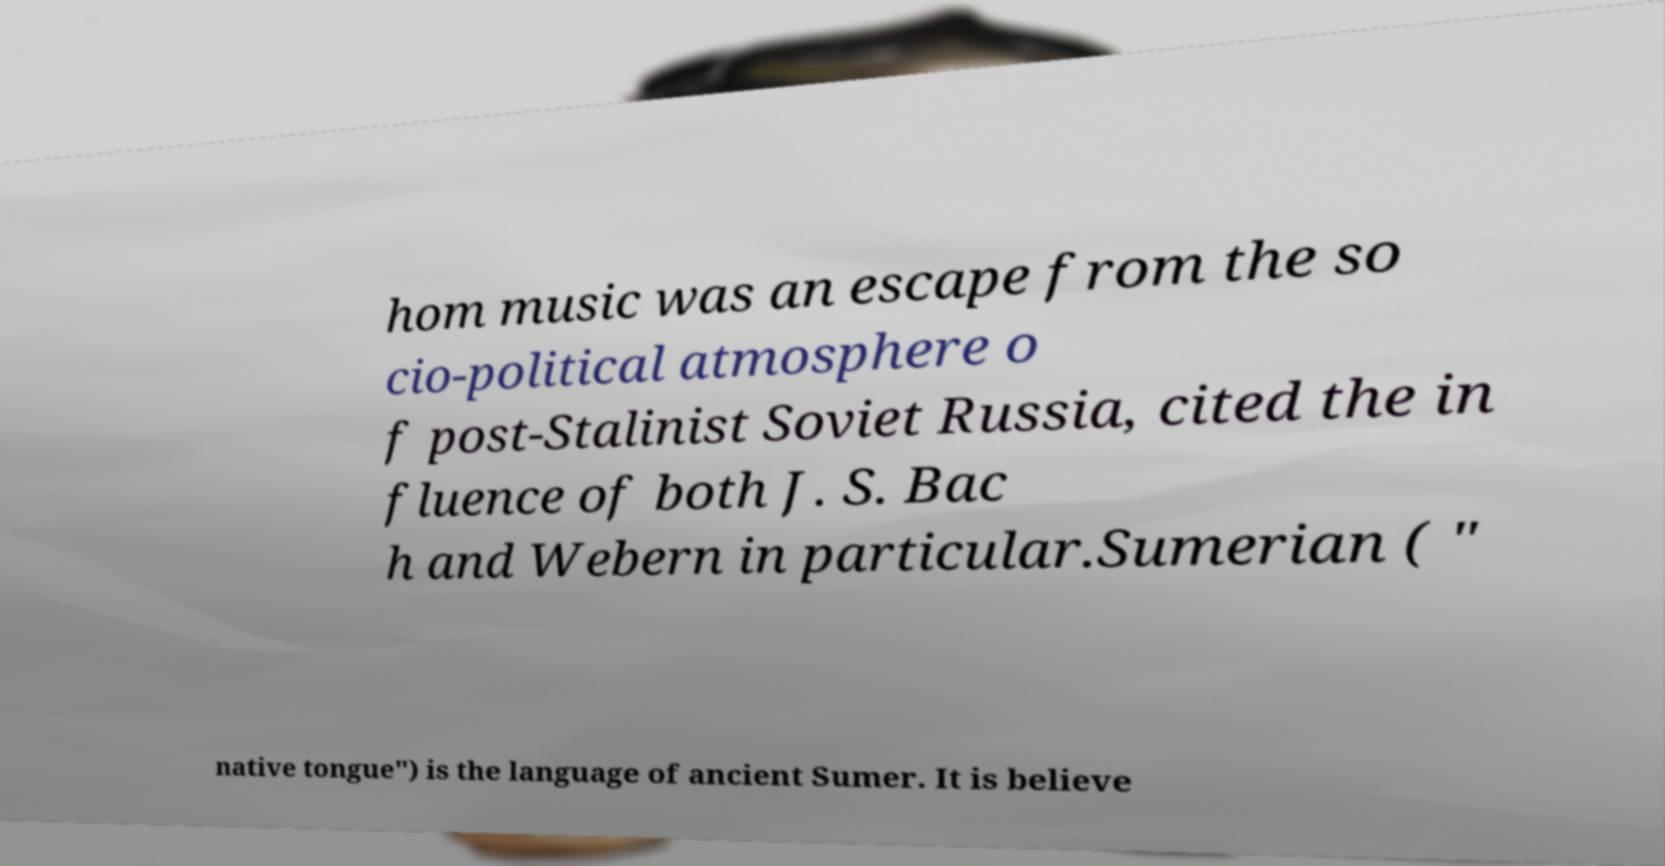There's text embedded in this image that I need extracted. Can you transcribe it verbatim? hom music was an escape from the so cio-political atmosphere o f post-Stalinist Soviet Russia, cited the in fluence of both J. S. Bac h and Webern in particular.Sumerian ( " native tongue") is the language of ancient Sumer. It is believe 